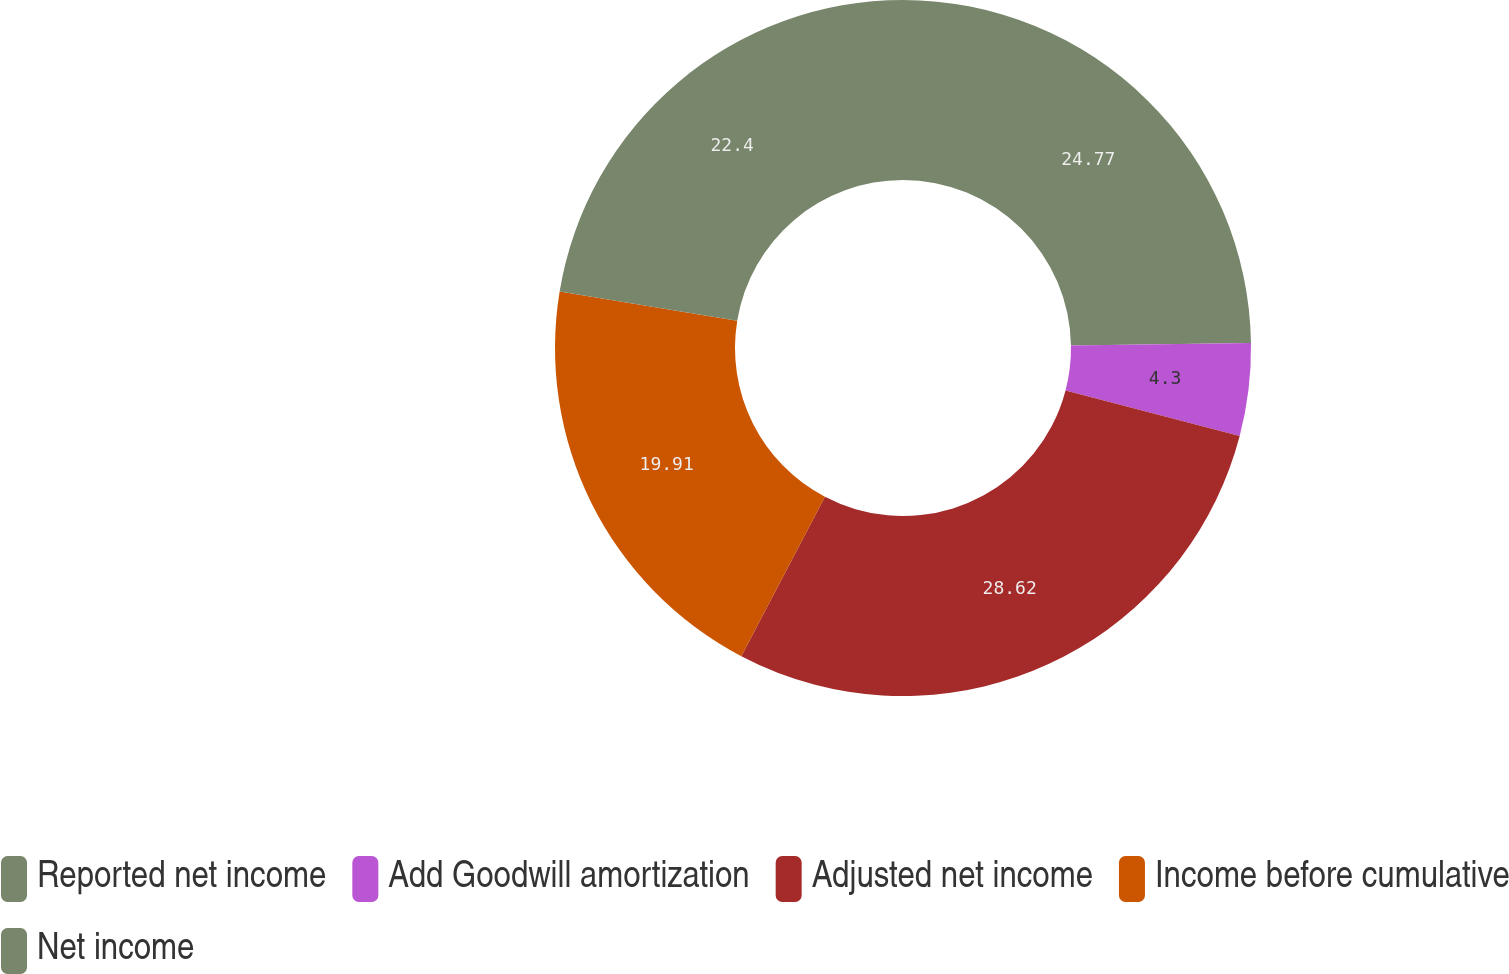Convert chart. <chart><loc_0><loc_0><loc_500><loc_500><pie_chart><fcel>Reported net income<fcel>Add Goodwill amortization<fcel>Adjusted net income<fcel>Income before cumulative<fcel>Net income<nl><fcel>24.77%<fcel>4.3%<fcel>28.62%<fcel>19.91%<fcel>22.4%<nl></chart> 